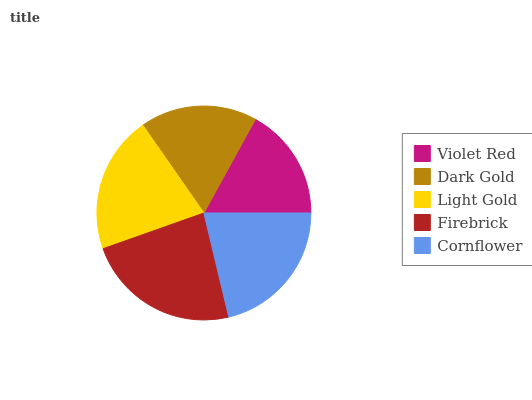Is Violet Red the minimum?
Answer yes or no. Yes. Is Firebrick the maximum?
Answer yes or no. Yes. Is Dark Gold the minimum?
Answer yes or no. No. Is Dark Gold the maximum?
Answer yes or no. No. Is Dark Gold greater than Violet Red?
Answer yes or no. Yes. Is Violet Red less than Dark Gold?
Answer yes or no. Yes. Is Violet Red greater than Dark Gold?
Answer yes or no. No. Is Dark Gold less than Violet Red?
Answer yes or no. No. Is Light Gold the high median?
Answer yes or no. Yes. Is Light Gold the low median?
Answer yes or no. Yes. Is Firebrick the high median?
Answer yes or no. No. Is Firebrick the low median?
Answer yes or no. No. 